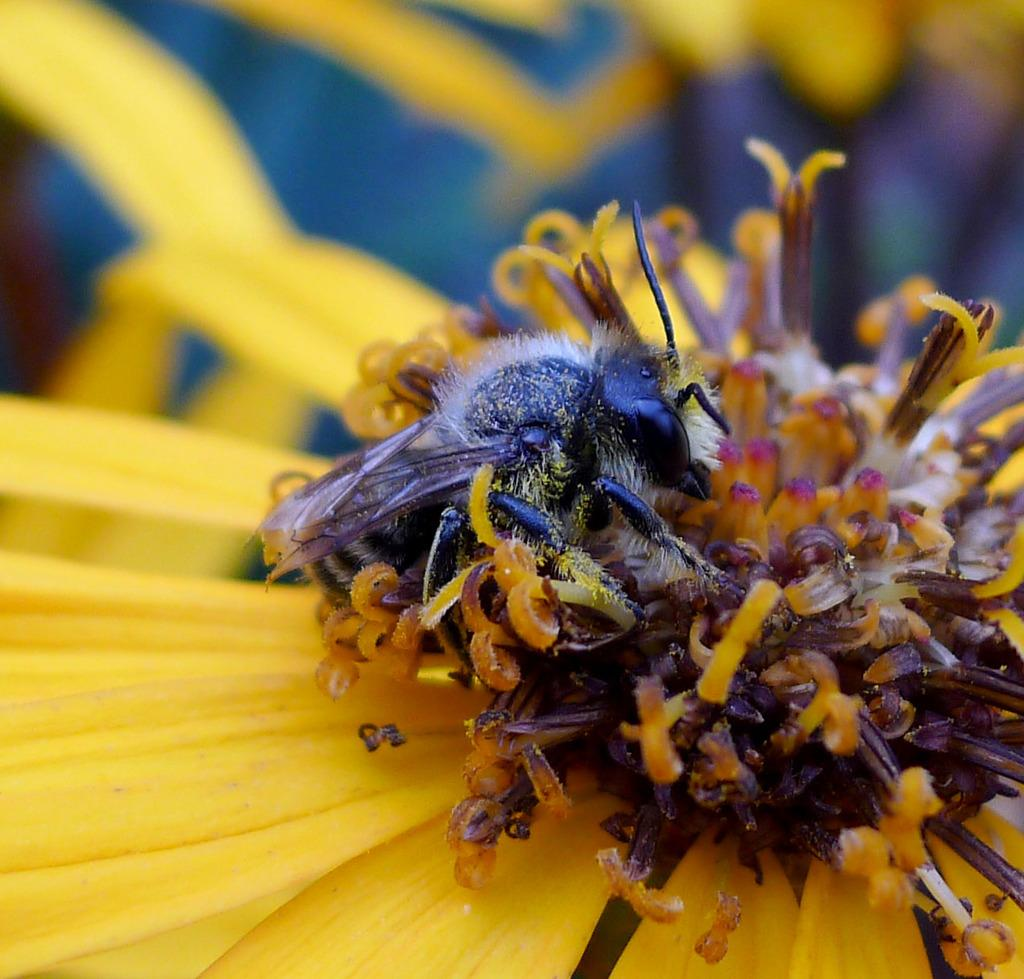What type of flower is present in the image? There is a yellow flower in the image. Is there anything else present on the flower? Yes, there is a black insect on the flower. Where is the nearest hospital to the location of the flower and insect in the image? The image does not provide any information about the location of the flower and insect, so it is impossible to determine the nearest hospital. 